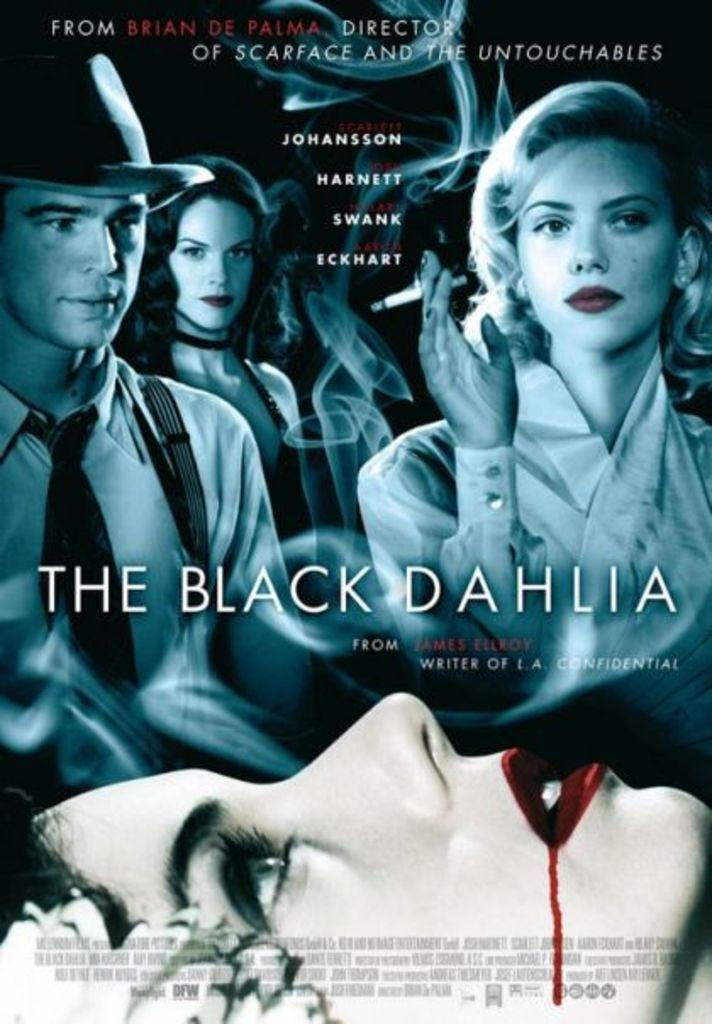<image>
Give a short and clear explanation of the subsequent image. Poster of themovie The Black Dahlia, picturing Scarlet Johanson. 